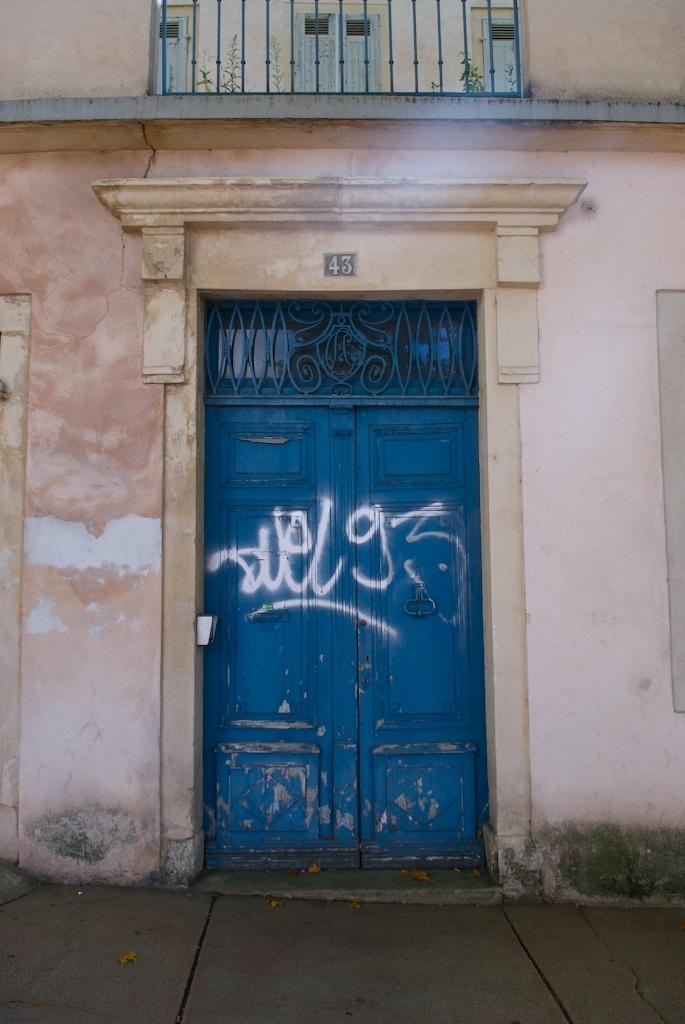Describe this image in one or two sentences. In this picture we can see few metal rods and doors, at the top of the image we can see few plants and we can find some text on the doors. 